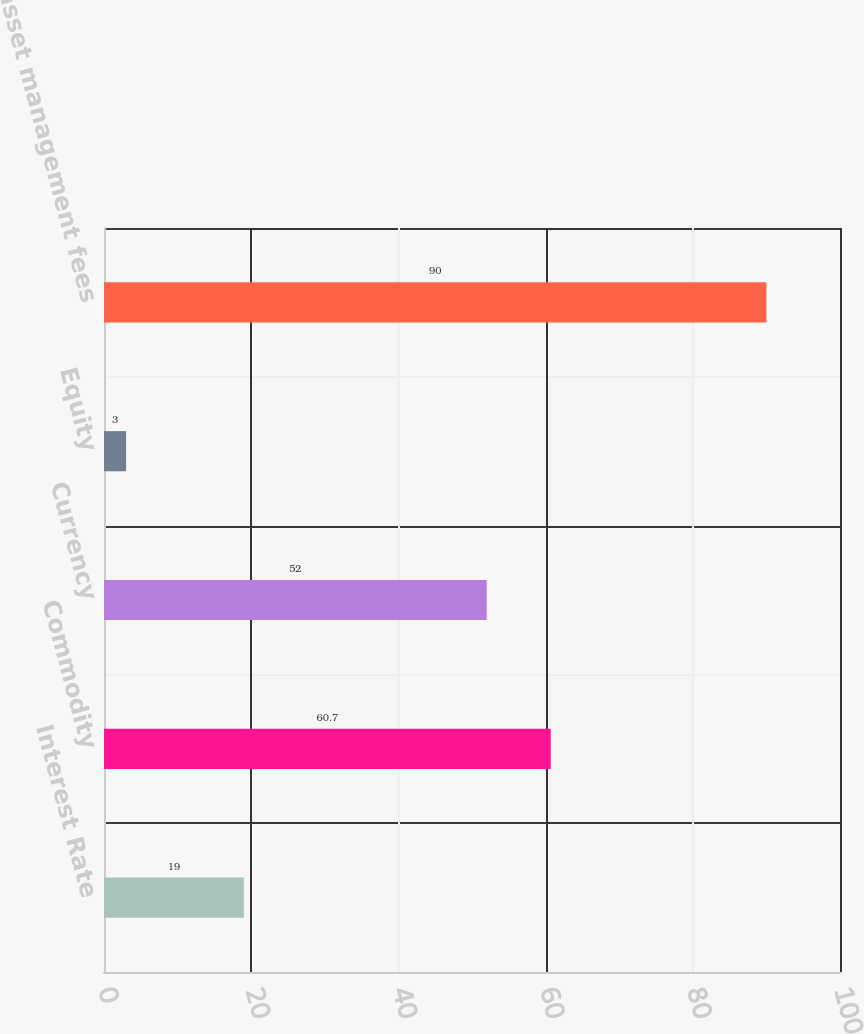Convert chart to OTSL. <chart><loc_0><loc_0><loc_500><loc_500><bar_chart><fcel>Interest Rate<fcel>Commodity<fcel>Currency<fcel>Equity<fcel>Total asset management fees<nl><fcel>19<fcel>60.7<fcel>52<fcel>3<fcel>90<nl></chart> 